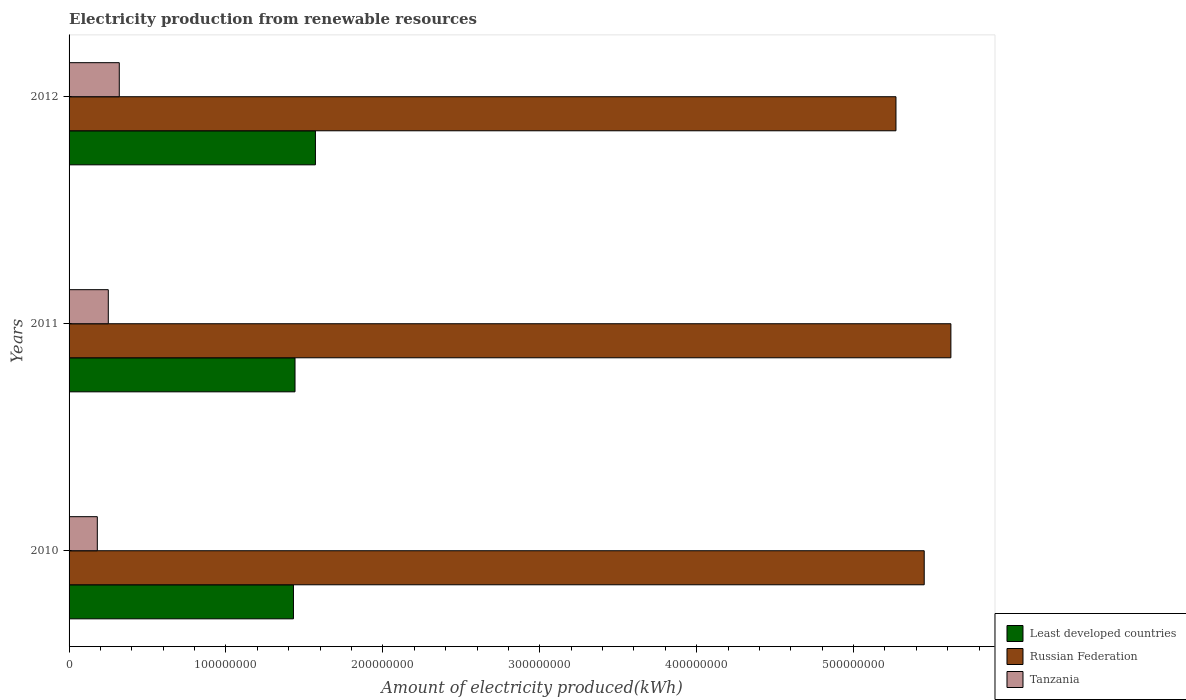How many groups of bars are there?
Your answer should be compact. 3. Are the number of bars per tick equal to the number of legend labels?
Keep it short and to the point. Yes. Are the number of bars on each tick of the Y-axis equal?
Provide a short and direct response. Yes. How many bars are there on the 3rd tick from the bottom?
Offer a terse response. 3. What is the label of the 1st group of bars from the top?
Your answer should be compact. 2012. What is the amount of electricity produced in Tanzania in 2011?
Offer a terse response. 2.50e+07. Across all years, what is the maximum amount of electricity produced in Least developed countries?
Give a very brief answer. 1.57e+08. Across all years, what is the minimum amount of electricity produced in Least developed countries?
Offer a terse response. 1.43e+08. In which year was the amount of electricity produced in Russian Federation maximum?
Offer a terse response. 2011. What is the total amount of electricity produced in Tanzania in the graph?
Your response must be concise. 7.50e+07. What is the difference between the amount of electricity produced in Russian Federation in 2011 and that in 2012?
Provide a succinct answer. 3.50e+07. What is the difference between the amount of electricity produced in Tanzania in 2010 and the amount of electricity produced in Least developed countries in 2012?
Provide a succinct answer. -1.39e+08. What is the average amount of electricity produced in Least developed countries per year?
Offer a very short reply. 1.48e+08. In the year 2011, what is the difference between the amount of electricity produced in Tanzania and amount of electricity produced in Russian Federation?
Your answer should be compact. -5.37e+08. In how many years, is the amount of electricity produced in Least developed countries greater than 120000000 kWh?
Ensure brevity in your answer.  3. What is the ratio of the amount of electricity produced in Least developed countries in 2011 to that in 2012?
Your answer should be compact. 0.92. What is the difference between the highest and the second highest amount of electricity produced in Russian Federation?
Keep it short and to the point. 1.70e+07. What is the difference between the highest and the lowest amount of electricity produced in Least developed countries?
Offer a terse response. 1.40e+07. What does the 1st bar from the top in 2012 represents?
Give a very brief answer. Tanzania. What does the 1st bar from the bottom in 2010 represents?
Offer a terse response. Least developed countries. Is it the case that in every year, the sum of the amount of electricity produced in Tanzania and amount of electricity produced in Russian Federation is greater than the amount of electricity produced in Least developed countries?
Provide a succinct answer. Yes. Are all the bars in the graph horizontal?
Your answer should be compact. Yes. Are the values on the major ticks of X-axis written in scientific E-notation?
Provide a succinct answer. No. Does the graph contain any zero values?
Provide a succinct answer. No. Does the graph contain grids?
Keep it short and to the point. No. Where does the legend appear in the graph?
Offer a terse response. Bottom right. How are the legend labels stacked?
Ensure brevity in your answer.  Vertical. What is the title of the graph?
Offer a very short reply. Electricity production from renewable resources. What is the label or title of the X-axis?
Offer a terse response. Amount of electricity produced(kWh). What is the Amount of electricity produced(kWh) in Least developed countries in 2010?
Make the answer very short. 1.43e+08. What is the Amount of electricity produced(kWh) in Russian Federation in 2010?
Give a very brief answer. 5.45e+08. What is the Amount of electricity produced(kWh) of Tanzania in 2010?
Offer a very short reply. 1.80e+07. What is the Amount of electricity produced(kWh) in Least developed countries in 2011?
Provide a short and direct response. 1.44e+08. What is the Amount of electricity produced(kWh) of Russian Federation in 2011?
Offer a terse response. 5.62e+08. What is the Amount of electricity produced(kWh) of Tanzania in 2011?
Ensure brevity in your answer.  2.50e+07. What is the Amount of electricity produced(kWh) of Least developed countries in 2012?
Keep it short and to the point. 1.57e+08. What is the Amount of electricity produced(kWh) of Russian Federation in 2012?
Your answer should be compact. 5.27e+08. What is the Amount of electricity produced(kWh) in Tanzania in 2012?
Offer a very short reply. 3.20e+07. Across all years, what is the maximum Amount of electricity produced(kWh) in Least developed countries?
Ensure brevity in your answer.  1.57e+08. Across all years, what is the maximum Amount of electricity produced(kWh) of Russian Federation?
Provide a succinct answer. 5.62e+08. Across all years, what is the maximum Amount of electricity produced(kWh) in Tanzania?
Offer a very short reply. 3.20e+07. Across all years, what is the minimum Amount of electricity produced(kWh) of Least developed countries?
Provide a succinct answer. 1.43e+08. Across all years, what is the minimum Amount of electricity produced(kWh) in Russian Federation?
Offer a terse response. 5.27e+08. Across all years, what is the minimum Amount of electricity produced(kWh) in Tanzania?
Your answer should be compact. 1.80e+07. What is the total Amount of electricity produced(kWh) in Least developed countries in the graph?
Offer a very short reply. 4.44e+08. What is the total Amount of electricity produced(kWh) in Russian Federation in the graph?
Your answer should be compact. 1.63e+09. What is the total Amount of electricity produced(kWh) in Tanzania in the graph?
Your answer should be compact. 7.50e+07. What is the difference between the Amount of electricity produced(kWh) of Least developed countries in 2010 and that in 2011?
Your answer should be very brief. -1.00e+06. What is the difference between the Amount of electricity produced(kWh) of Russian Federation in 2010 and that in 2011?
Give a very brief answer. -1.70e+07. What is the difference between the Amount of electricity produced(kWh) of Tanzania in 2010 and that in 2011?
Give a very brief answer. -7.00e+06. What is the difference between the Amount of electricity produced(kWh) of Least developed countries in 2010 and that in 2012?
Your answer should be compact. -1.40e+07. What is the difference between the Amount of electricity produced(kWh) of Russian Federation in 2010 and that in 2012?
Provide a short and direct response. 1.80e+07. What is the difference between the Amount of electricity produced(kWh) in Tanzania in 2010 and that in 2012?
Make the answer very short. -1.40e+07. What is the difference between the Amount of electricity produced(kWh) in Least developed countries in 2011 and that in 2012?
Offer a terse response. -1.30e+07. What is the difference between the Amount of electricity produced(kWh) of Russian Federation in 2011 and that in 2012?
Ensure brevity in your answer.  3.50e+07. What is the difference between the Amount of electricity produced(kWh) of Tanzania in 2011 and that in 2012?
Provide a short and direct response. -7.00e+06. What is the difference between the Amount of electricity produced(kWh) of Least developed countries in 2010 and the Amount of electricity produced(kWh) of Russian Federation in 2011?
Provide a short and direct response. -4.19e+08. What is the difference between the Amount of electricity produced(kWh) in Least developed countries in 2010 and the Amount of electricity produced(kWh) in Tanzania in 2011?
Make the answer very short. 1.18e+08. What is the difference between the Amount of electricity produced(kWh) in Russian Federation in 2010 and the Amount of electricity produced(kWh) in Tanzania in 2011?
Give a very brief answer. 5.20e+08. What is the difference between the Amount of electricity produced(kWh) in Least developed countries in 2010 and the Amount of electricity produced(kWh) in Russian Federation in 2012?
Offer a terse response. -3.84e+08. What is the difference between the Amount of electricity produced(kWh) of Least developed countries in 2010 and the Amount of electricity produced(kWh) of Tanzania in 2012?
Make the answer very short. 1.11e+08. What is the difference between the Amount of electricity produced(kWh) in Russian Federation in 2010 and the Amount of electricity produced(kWh) in Tanzania in 2012?
Make the answer very short. 5.13e+08. What is the difference between the Amount of electricity produced(kWh) of Least developed countries in 2011 and the Amount of electricity produced(kWh) of Russian Federation in 2012?
Provide a short and direct response. -3.83e+08. What is the difference between the Amount of electricity produced(kWh) of Least developed countries in 2011 and the Amount of electricity produced(kWh) of Tanzania in 2012?
Your answer should be compact. 1.12e+08. What is the difference between the Amount of electricity produced(kWh) of Russian Federation in 2011 and the Amount of electricity produced(kWh) of Tanzania in 2012?
Keep it short and to the point. 5.30e+08. What is the average Amount of electricity produced(kWh) in Least developed countries per year?
Keep it short and to the point. 1.48e+08. What is the average Amount of electricity produced(kWh) of Russian Federation per year?
Your answer should be compact. 5.45e+08. What is the average Amount of electricity produced(kWh) in Tanzania per year?
Ensure brevity in your answer.  2.50e+07. In the year 2010, what is the difference between the Amount of electricity produced(kWh) of Least developed countries and Amount of electricity produced(kWh) of Russian Federation?
Your answer should be compact. -4.02e+08. In the year 2010, what is the difference between the Amount of electricity produced(kWh) in Least developed countries and Amount of electricity produced(kWh) in Tanzania?
Make the answer very short. 1.25e+08. In the year 2010, what is the difference between the Amount of electricity produced(kWh) of Russian Federation and Amount of electricity produced(kWh) of Tanzania?
Offer a very short reply. 5.27e+08. In the year 2011, what is the difference between the Amount of electricity produced(kWh) of Least developed countries and Amount of electricity produced(kWh) of Russian Federation?
Make the answer very short. -4.18e+08. In the year 2011, what is the difference between the Amount of electricity produced(kWh) in Least developed countries and Amount of electricity produced(kWh) in Tanzania?
Make the answer very short. 1.19e+08. In the year 2011, what is the difference between the Amount of electricity produced(kWh) of Russian Federation and Amount of electricity produced(kWh) of Tanzania?
Your answer should be very brief. 5.37e+08. In the year 2012, what is the difference between the Amount of electricity produced(kWh) in Least developed countries and Amount of electricity produced(kWh) in Russian Federation?
Provide a succinct answer. -3.70e+08. In the year 2012, what is the difference between the Amount of electricity produced(kWh) of Least developed countries and Amount of electricity produced(kWh) of Tanzania?
Provide a short and direct response. 1.25e+08. In the year 2012, what is the difference between the Amount of electricity produced(kWh) in Russian Federation and Amount of electricity produced(kWh) in Tanzania?
Your response must be concise. 4.95e+08. What is the ratio of the Amount of electricity produced(kWh) of Russian Federation in 2010 to that in 2011?
Your answer should be compact. 0.97. What is the ratio of the Amount of electricity produced(kWh) of Tanzania in 2010 to that in 2011?
Your answer should be compact. 0.72. What is the ratio of the Amount of electricity produced(kWh) in Least developed countries in 2010 to that in 2012?
Provide a short and direct response. 0.91. What is the ratio of the Amount of electricity produced(kWh) of Russian Federation in 2010 to that in 2012?
Offer a very short reply. 1.03. What is the ratio of the Amount of electricity produced(kWh) in Tanzania in 2010 to that in 2012?
Offer a terse response. 0.56. What is the ratio of the Amount of electricity produced(kWh) in Least developed countries in 2011 to that in 2012?
Your answer should be very brief. 0.92. What is the ratio of the Amount of electricity produced(kWh) of Russian Federation in 2011 to that in 2012?
Make the answer very short. 1.07. What is the ratio of the Amount of electricity produced(kWh) in Tanzania in 2011 to that in 2012?
Your answer should be compact. 0.78. What is the difference between the highest and the second highest Amount of electricity produced(kWh) in Least developed countries?
Keep it short and to the point. 1.30e+07. What is the difference between the highest and the second highest Amount of electricity produced(kWh) of Russian Federation?
Ensure brevity in your answer.  1.70e+07. What is the difference between the highest and the second highest Amount of electricity produced(kWh) of Tanzania?
Your response must be concise. 7.00e+06. What is the difference between the highest and the lowest Amount of electricity produced(kWh) in Least developed countries?
Keep it short and to the point. 1.40e+07. What is the difference between the highest and the lowest Amount of electricity produced(kWh) of Russian Federation?
Keep it short and to the point. 3.50e+07. What is the difference between the highest and the lowest Amount of electricity produced(kWh) in Tanzania?
Ensure brevity in your answer.  1.40e+07. 